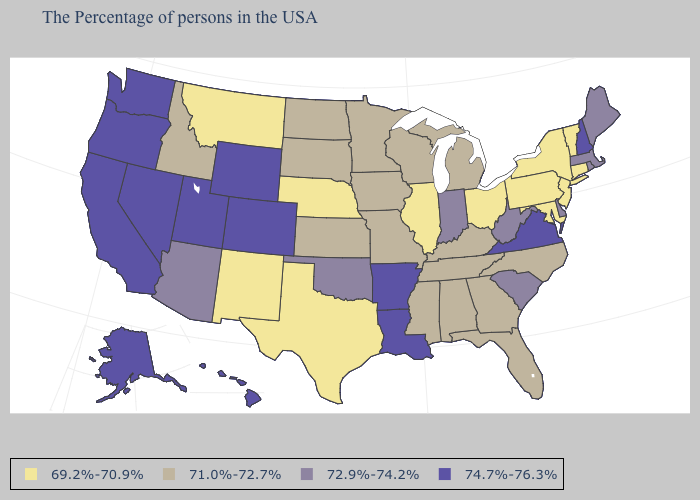Does the first symbol in the legend represent the smallest category?
Short answer required. Yes. Which states hav the highest value in the Northeast?
Concise answer only. New Hampshire. What is the value of Iowa?
Answer briefly. 71.0%-72.7%. What is the value of Vermont?
Answer briefly. 69.2%-70.9%. What is the lowest value in states that border Delaware?
Keep it brief. 69.2%-70.9%. How many symbols are there in the legend?
Be succinct. 4. Name the states that have a value in the range 72.9%-74.2%?
Concise answer only. Maine, Massachusetts, Rhode Island, Delaware, South Carolina, West Virginia, Indiana, Oklahoma, Arizona. What is the value of Illinois?
Be succinct. 69.2%-70.9%. Does Alaska have the lowest value in the West?
Give a very brief answer. No. Name the states that have a value in the range 69.2%-70.9%?
Answer briefly. Vermont, Connecticut, New York, New Jersey, Maryland, Pennsylvania, Ohio, Illinois, Nebraska, Texas, New Mexico, Montana. Is the legend a continuous bar?
Answer briefly. No. Does Arizona have the same value as West Virginia?
Answer briefly. Yes. Name the states that have a value in the range 71.0%-72.7%?
Short answer required. North Carolina, Florida, Georgia, Michigan, Kentucky, Alabama, Tennessee, Wisconsin, Mississippi, Missouri, Minnesota, Iowa, Kansas, South Dakota, North Dakota, Idaho. Name the states that have a value in the range 69.2%-70.9%?
Short answer required. Vermont, Connecticut, New York, New Jersey, Maryland, Pennsylvania, Ohio, Illinois, Nebraska, Texas, New Mexico, Montana. What is the lowest value in states that border Ohio?
Keep it brief. 69.2%-70.9%. 